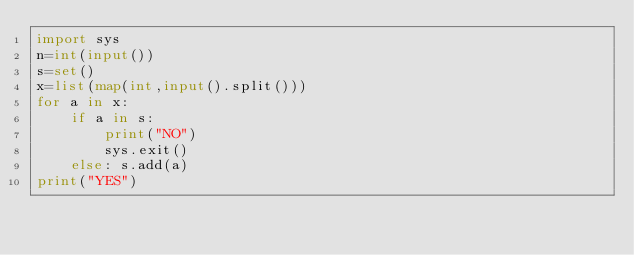Convert code to text. <code><loc_0><loc_0><loc_500><loc_500><_Python_>import sys
n=int(input())
s=set()
x=list(map(int,input().split()))
for a in x:
    if a in s:
        print("NO")
        sys.exit()
    else: s.add(a)
print("YES")</code> 